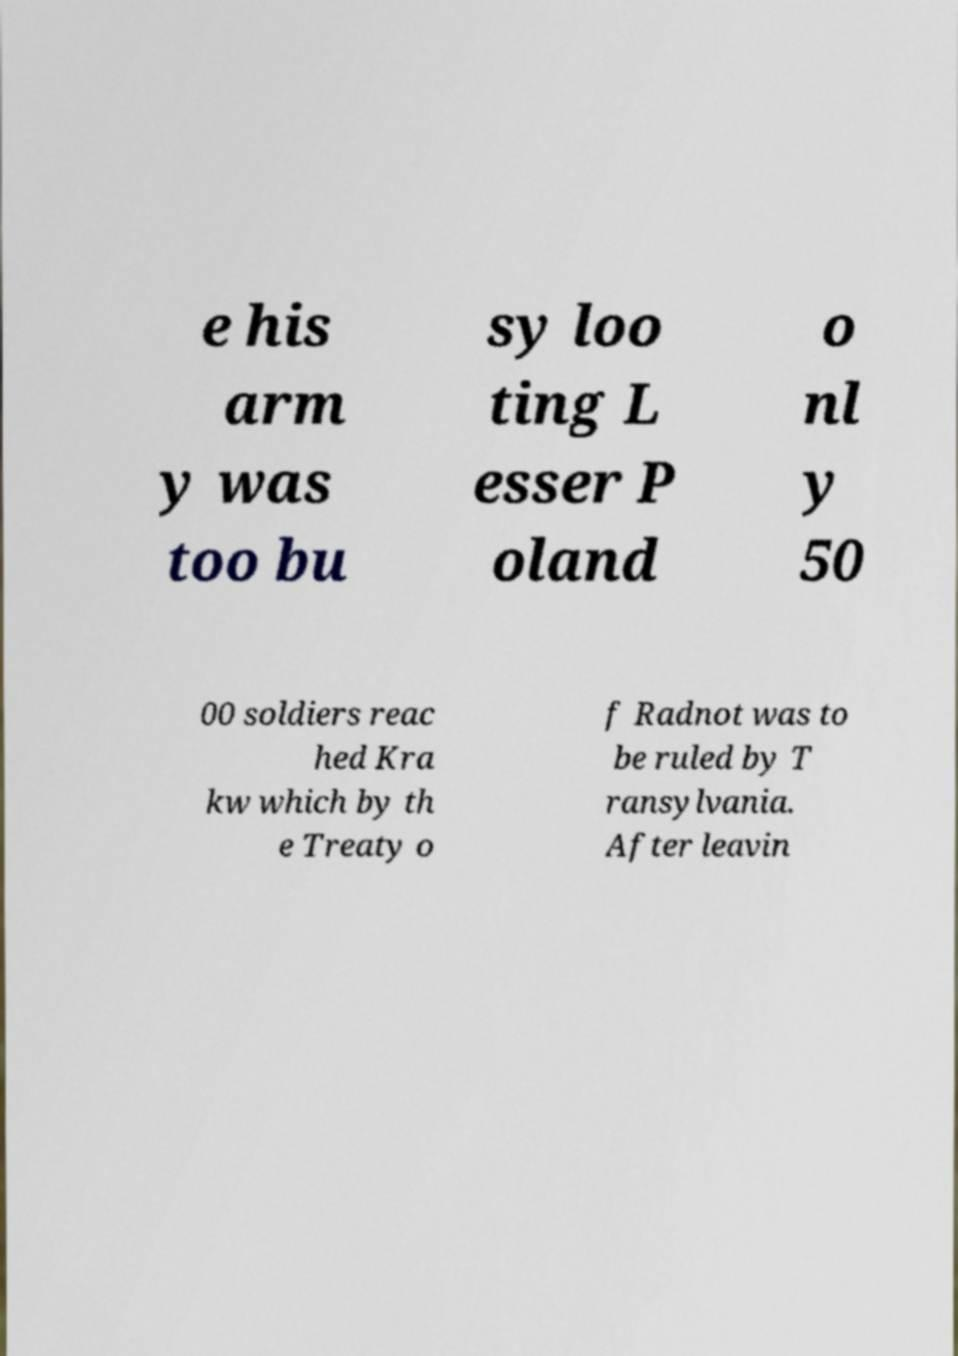Please identify and transcribe the text found in this image. e his arm y was too bu sy loo ting L esser P oland o nl y 50 00 soldiers reac hed Kra kw which by th e Treaty o f Radnot was to be ruled by T ransylvania. After leavin 